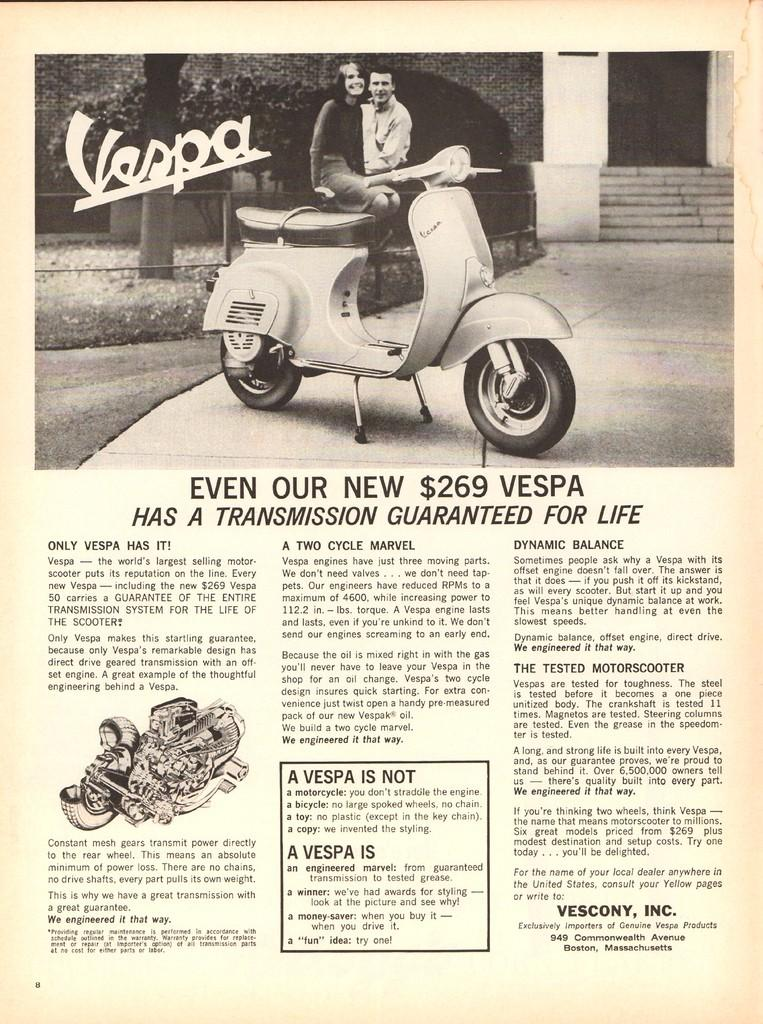What is depicted on the paper in the image? The paper contains a drawing or image of a scooter. How many people are in the image? There are two persons in the image. What can be seen in the background of the image? There is a building in the image. Is there any text present in the image? Yes, there is text at the bottom of the image. What type of liquid is being poured into the crib in the image? There is no crib or liquid present in the image. How many hands are visible in the image? The provided facts do not mention the visibility of hands, so we cannot definitively answer this question. 